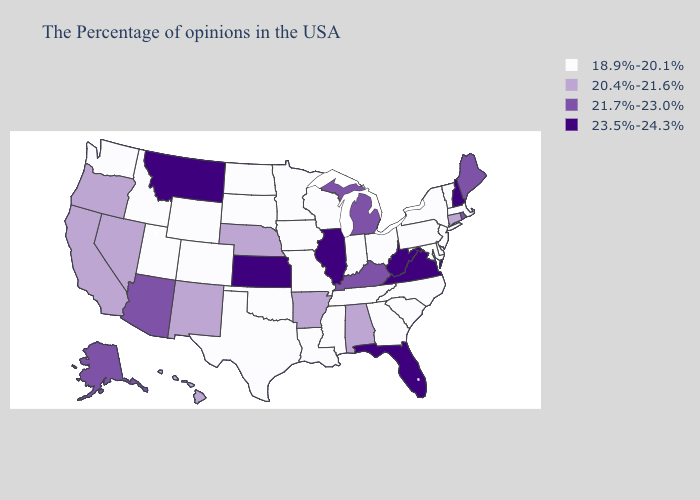Name the states that have a value in the range 21.7%-23.0%?
Be succinct. Maine, Rhode Island, Michigan, Kentucky, Arizona, Alaska. What is the value of Louisiana?
Keep it brief. 18.9%-20.1%. What is the highest value in the Northeast ?
Keep it brief. 23.5%-24.3%. Name the states that have a value in the range 20.4%-21.6%?
Answer briefly. Connecticut, Alabama, Arkansas, Nebraska, New Mexico, Nevada, California, Oregon, Hawaii. Name the states that have a value in the range 18.9%-20.1%?
Give a very brief answer. Massachusetts, Vermont, New York, New Jersey, Delaware, Maryland, Pennsylvania, North Carolina, South Carolina, Ohio, Georgia, Indiana, Tennessee, Wisconsin, Mississippi, Louisiana, Missouri, Minnesota, Iowa, Oklahoma, Texas, South Dakota, North Dakota, Wyoming, Colorado, Utah, Idaho, Washington. Name the states that have a value in the range 23.5%-24.3%?
Short answer required. New Hampshire, Virginia, West Virginia, Florida, Illinois, Kansas, Montana. Does the first symbol in the legend represent the smallest category?
Keep it brief. Yes. What is the highest value in states that border Washington?
Short answer required. 20.4%-21.6%. Does Illinois have the lowest value in the MidWest?
Answer briefly. No. Name the states that have a value in the range 23.5%-24.3%?
Write a very short answer. New Hampshire, Virginia, West Virginia, Florida, Illinois, Kansas, Montana. What is the lowest value in states that border North Dakota?
Short answer required. 18.9%-20.1%. Name the states that have a value in the range 21.7%-23.0%?
Give a very brief answer. Maine, Rhode Island, Michigan, Kentucky, Arizona, Alaska. What is the value of Connecticut?
Be succinct. 20.4%-21.6%. Name the states that have a value in the range 18.9%-20.1%?
Write a very short answer. Massachusetts, Vermont, New York, New Jersey, Delaware, Maryland, Pennsylvania, North Carolina, South Carolina, Ohio, Georgia, Indiana, Tennessee, Wisconsin, Mississippi, Louisiana, Missouri, Minnesota, Iowa, Oklahoma, Texas, South Dakota, North Dakota, Wyoming, Colorado, Utah, Idaho, Washington. Does the map have missing data?
Short answer required. No. 